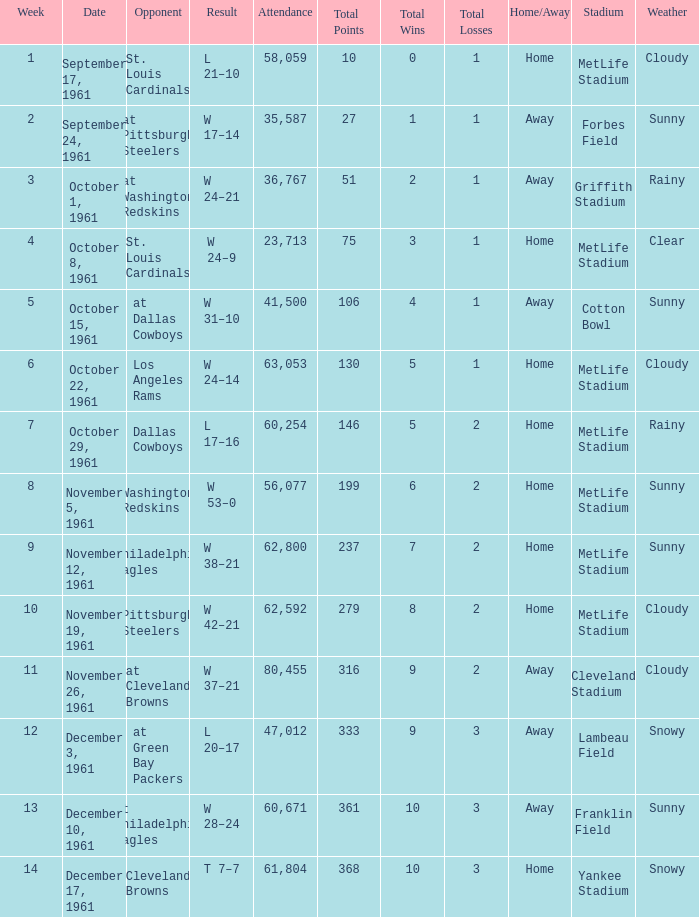Which Week has an Opponent of washington redskins, and an Attendance larger than 56,077? 0.0. 